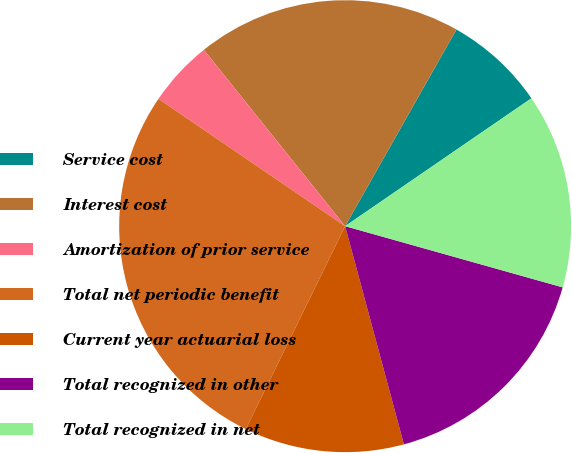Convert chart. <chart><loc_0><loc_0><loc_500><loc_500><pie_chart><fcel>Service cost<fcel>Interest cost<fcel>Amortization of prior service<fcel>Total net periodic benefit<fcel>Current year actuarial loss<fcel>Total recognized in other<fcel>Total recognized in net<nl><fcel>7.23%<fcel>18.95%<fcel>4.72%<fcel>27.29%<fcel>11.43%<fcel>16.45%<fcel>13.94%<nl></chart> 